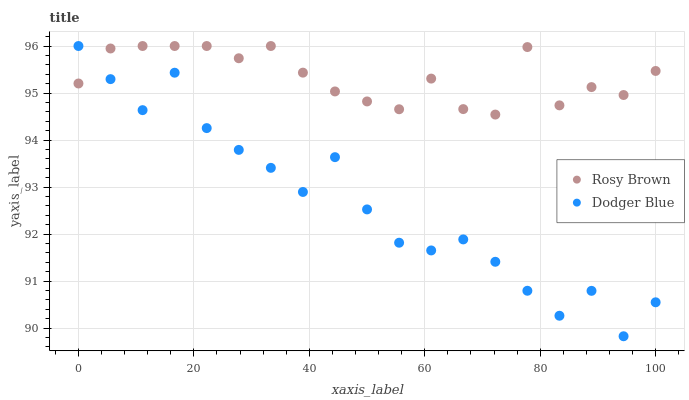Does Dodger Blue have the minimum area under the curve?
Answer yes or no. Yes. Does Rosy Brown have the maximum area under the curve?
Answer yes or no. Yes. Does Dodger Blue have the maximum area under the curve?
Answer yes or no. No. Is Rosy Brown the smoothest?
Answer yes or no. Yes. Is Dodger Blue the roughest?
Answer yes or no. Yes. Is Dodger Blue the smoothest?
Answer yes or no. No. Does Dodger Blue have the lowest value?
Answer yes or no. Yes. Does Dodger Blue have the highest value?
Answer yes or no. Yes. Does Dodger Blue intersect Rosy Brown?
Answer yes or no. Yes. Is Dodger Blue less than Rosy Brown?
Answer yes or no. No. Is Dodger Blue greater than Rosy Brown?
Answer yes or no. No. 